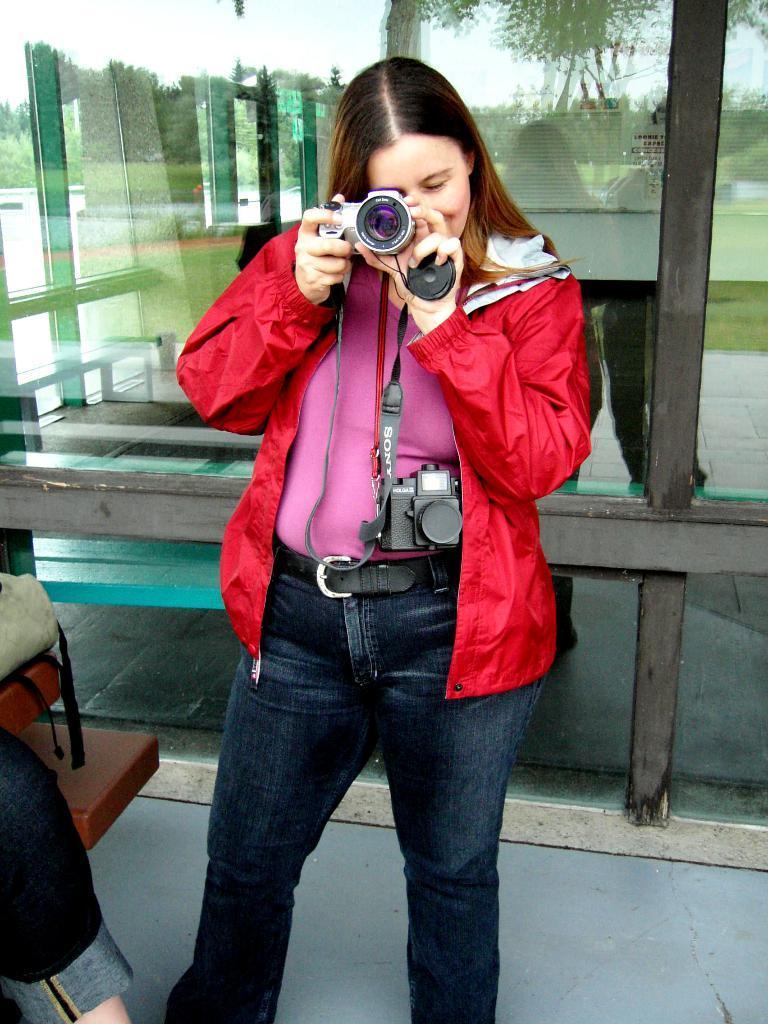Who is the main subject in the image? There is a girl in the image. What is the girl wearing? The girl is wearing a red jacket. What is the girl doing in the image? The girl is standing and holding a camera. What can be seen in the glass in the image? There is a reflection of trees and a building in the glass. What is the condition of the orange on the dock in the image? There is no orange or dock present in the image. 